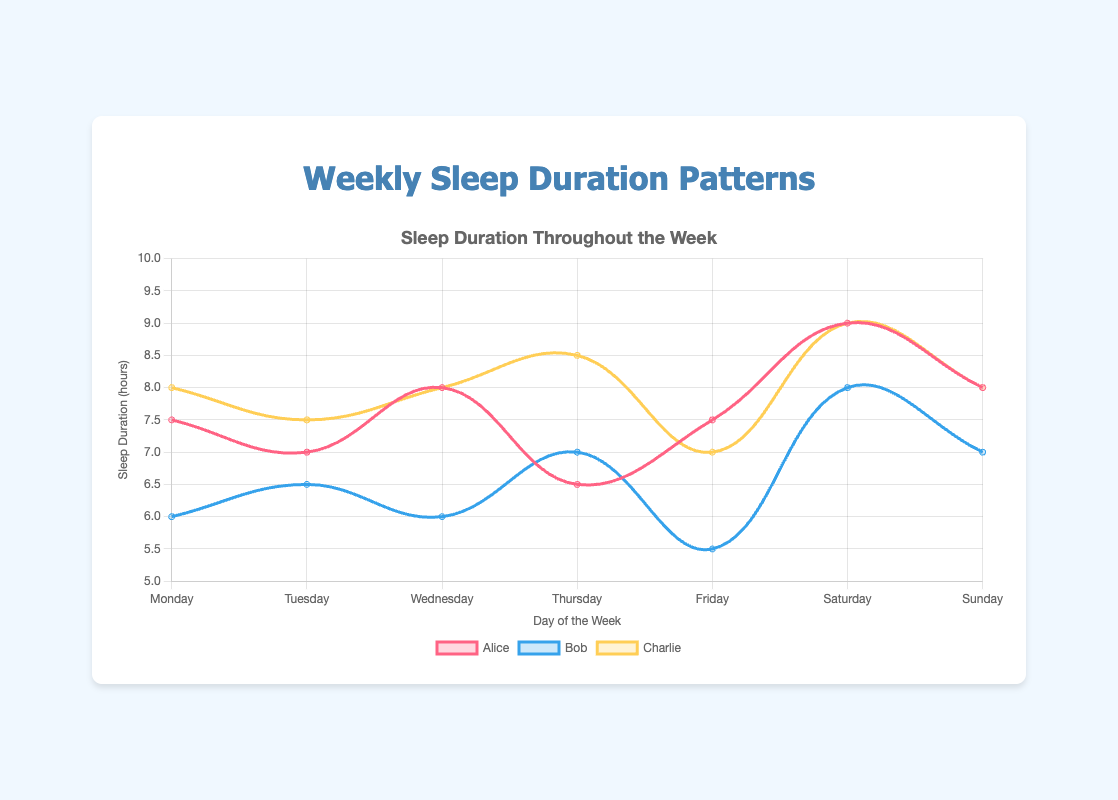What day did Bob have the shortest sleep duration? Bob's sleep durations for each day are as follows: Monday (6.0 hours), Tuesday (6.5 hours), Wednesday (6.0 hours), Thursday (7.0 hours), Friday (5.5 hours), Saturday (8.0 hours), and Sunday (7.0 hours). The shortest sleep duration is 5.5 hours, which occurred on Friday.
Answer: Friday On what day did all three individuals (Alice, Bob, and Charlie) have the same sleep duration? To determine the day when all three people had the same sleep duration, we compare their sleep durations day by day: Monday (Alice 7.5, Bob 6.0, Charlie 8.0), Tuesday (Alice 7.0, Bob 6.5, Charlie 7.5), Wednesday (Alice 8.0, Bob 6.0, Charlie 8.0), Thursday (Alice 6.5, Bob 7.0, Charlie 8.5), Friday (Alice 7.5, Bob 5.5, Charlie 7.0), Saturday (Alice 9.0, Bob 8.0, Charlie 9.0), Sunday (Alice 8.0, Bob 7.0, Charlie 8.0). No day met this criterion.
Answer: None Which person had the most consistent sleep duration throughout the week? To find the most consistent sleep pattern, we calculate the variance in sleep duration for each person:
- Alice: (0.25, 0, 1, 2.25, 0.25, 1.0, 0) = 4.75
- Bob: (1.0, 0.25, 1.0, 0.25, 2.25, 1.0, 0.25) = 6.0
- Charlie: (2.25, 0.25, 0, 2.25, 0.25, 1.0, 0) = 6.0
Alice has the lowest variance, indicating she was the most consistent.
Answer: Alice What was the average sleep duration for Charlie over the week? To find the average sleep duration for Charlie, sum his sleep durations over the week (8.0, 7.5, 8.0, 8.5, 7.0, 9.0, 8.0) and divide by 7: (8.0 + 7.5 + 8.0 + 8.5 + 7.0 + 9.0 + 8.0) / 7 = 56.0 / 7 = 8.0
Answer: 8.0 Who had the longest single sleep duration and on which day? Reviewing the data, the longest sleep duration was 9.0 hours, achieved by two individuals: Alice on Saturday and Charlie on Saturday.
Answer: Alice and Charlie, Saturday On which day did the total sleep duration for all three individuals add up to 24 hours? The daily total sleep durations are:
- Monday: 7.5 + 6.0 + 8.0 = 21.5
- Tuesday: 7.0 + 6.5 + 7.5 = 21.0
- Wednesday: 8.0 + 6.0 + 8.0 = 22.0
- Thursday: 6.5 + 7.0 + 8.5 = 22.0
- Friday: 7.5 + 5.5 + 7.0 = 20.0
- Saturday: 9.0 + 8.0 + 9.0 = 26.0
- Sunday: 8.0 + 7.0 + 8.0 = 23.0
No day had a total of 24 hours.
Answer: None 